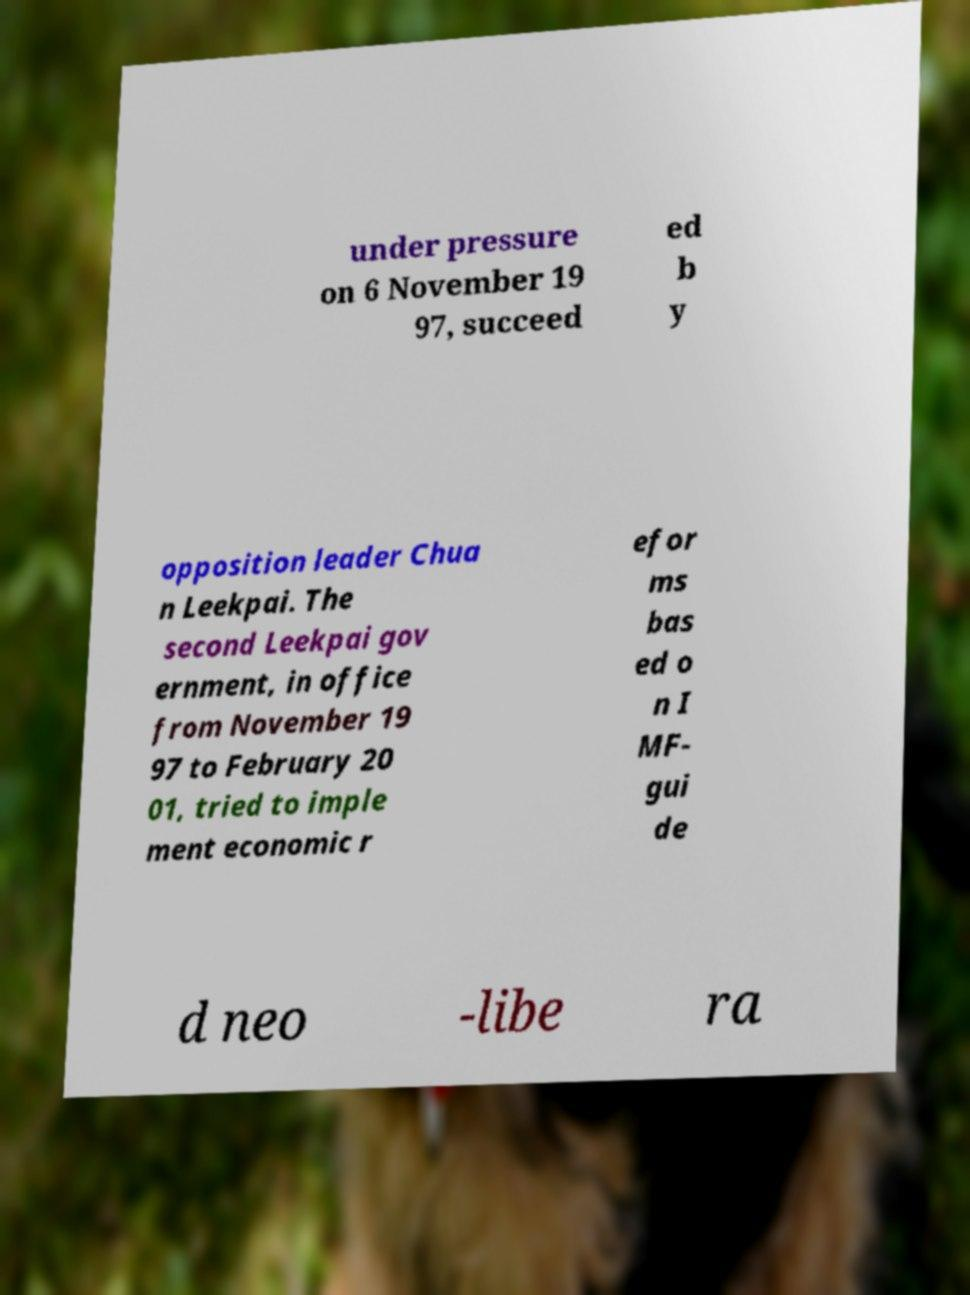What messages or text are displayed in this image? I need them in a readable, typed format. under pressure on 6 November 19 97, succeed ed b y opposition leader Chua n Leekpai. The second Leekpai gov ernment, in office from November 19 97 to February 20 01, tried to imple ment economic r efor ms bas ed o n I MF- gui de d neo -libe ra 